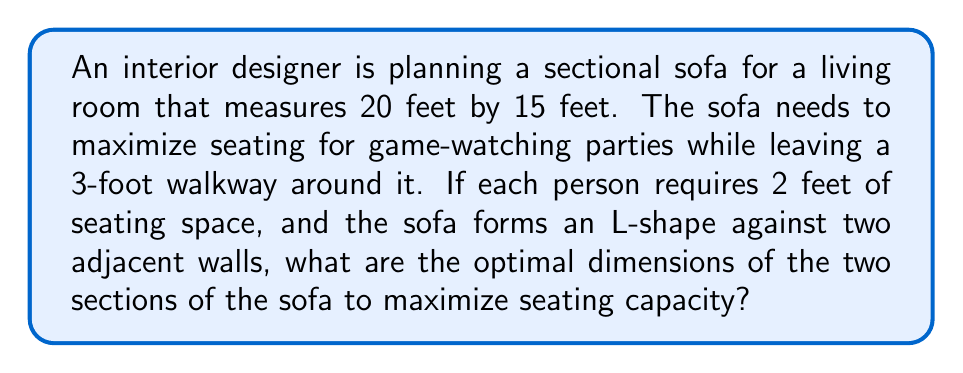Show me your answer to this math problem. Let's approach this step-by-step:

1) First, we need to calculate the available space for the sofa:
   - Room dimensions: 20 ft x 15 ft
   - Walkway: 3 ft on two sides
   - Available space: $(20-3)$ ft x $(15-3)$ ft = 17 ft x 12 ft

2) Let's define variables:
   - Let $x$ be the length of the sofa along the 17 ft wall
   - Let $y$ be the length of the sofa along the 12 ft wall

3) The total seating capacity will be:
   $\text{Capacity} = \frac{x}{2} + \frac{y}{2}$ (since each person needs 2 ft)

4) We want to maximize this, subject to the constraints:
   $0 \leq x \leq 17$ and $0 \leq y \leq 12$

5) The maximum will occur when we use the full available space:
   $x = 17$ and $y = 12$

6) Therefore, the optimal dimensions are:
   - One section: 17 ft
   - Other section: 12 ft

7) The maximum seating capacity will be:
   $\text{Capacity} = \frac{17}{2} + \frac{12}{2} = 8.5 + 6 = 14.5$

8) Since we can't have half a person, we round down to 14.

Therefore, the optimal dimensions for the sectional sofa are 17 feet and 12 feet, which will seat 14 people maximum.
Answer: 17 ft and 12 ft 